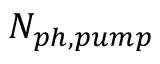<formula> <loc_0><loc_0><loc_500><loc_500>N _ { p h , p u m p }</formula> 